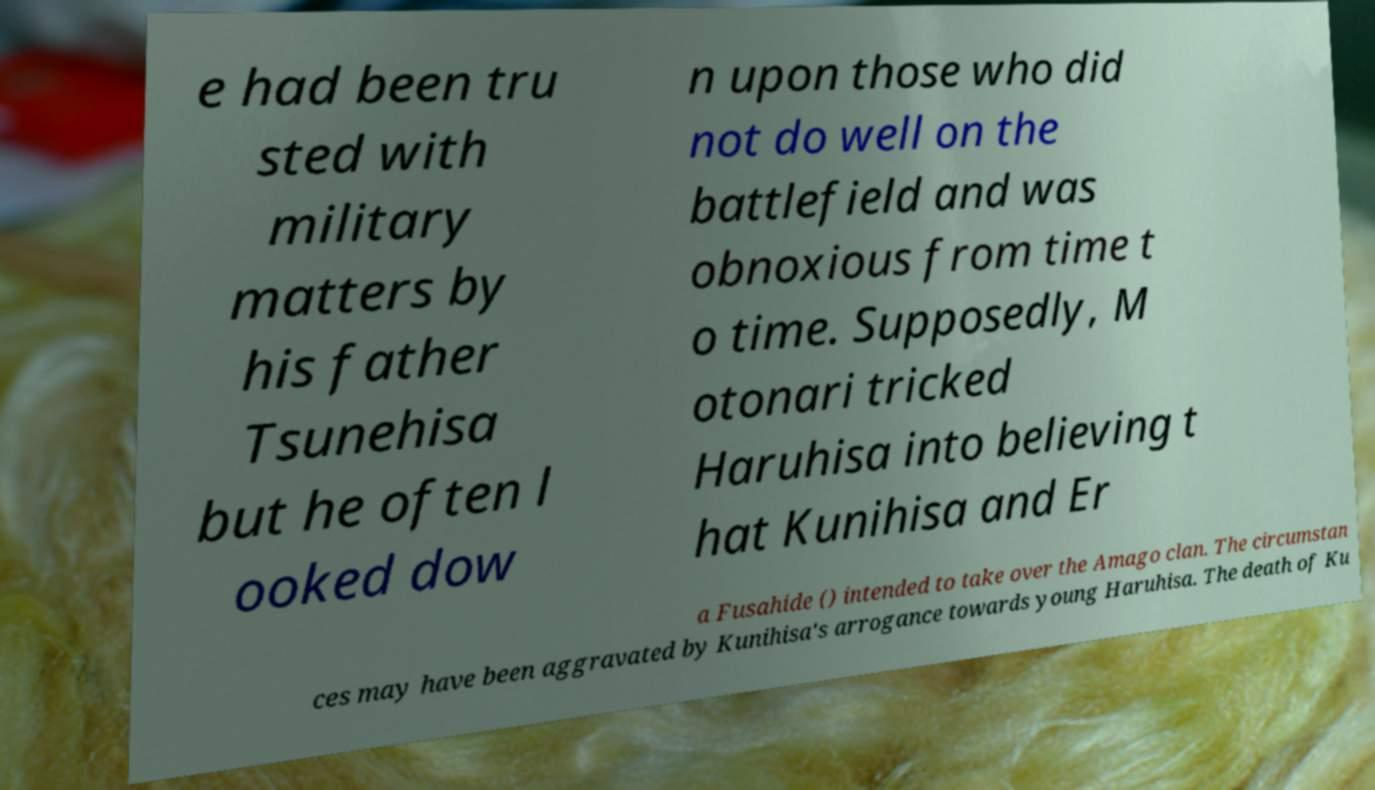What messages or text are displayed in this image? I need them in a readable, typed format. e had been tru sted with military matters by his father Tsunehisa but he often l ooked dow n upon those who did not do well on the battlefield and was obnoxious from time t o time. Supposedly, M otonari tricked Haruhisa into believing t hat Kunihisa and Er a Fusahide () intended to take over the Amago clan. The circumstan ces may have been aggravated by Kunihisa's arrogance towards young Haruhisa. The death of Ku 